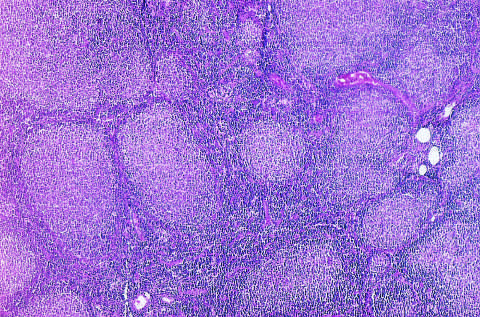re the segregation of b cells and t cells in different regions of the lymph node present throughout?
Answer the question using a single word or phrase. No 